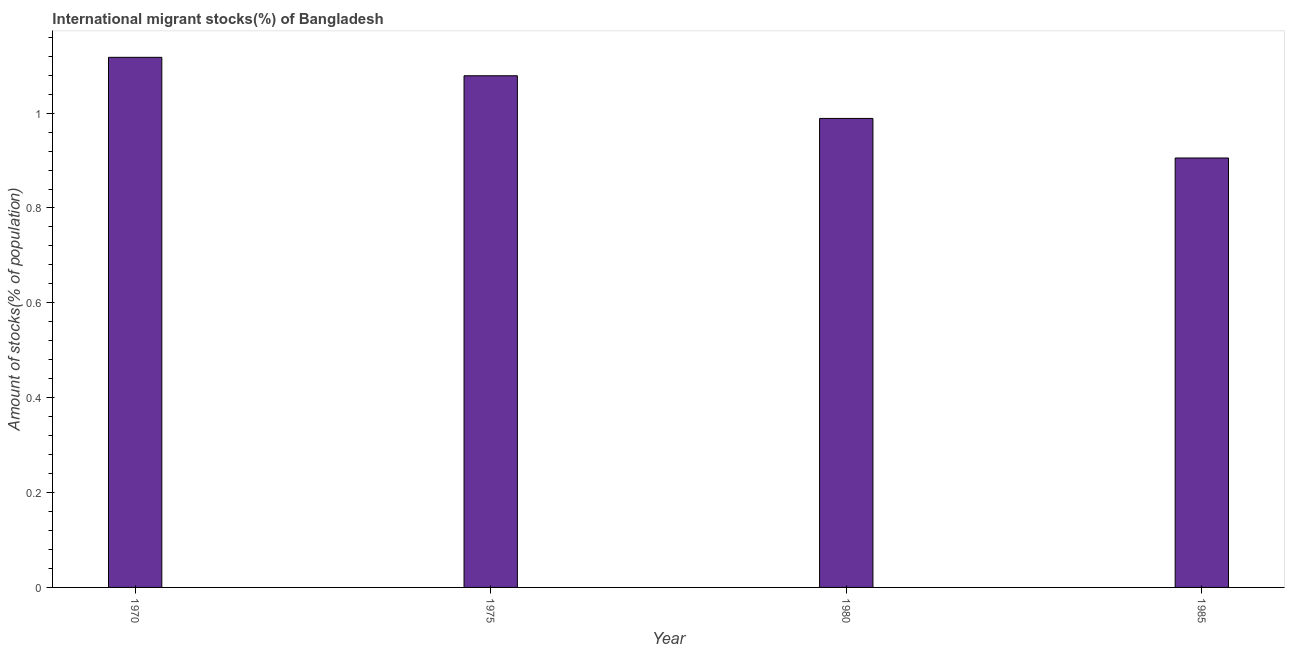What is the title of the graph?
Your answer should be very brief. International migrant stocks(%) of Bangladesh. What is the label or title of the Y-axis?
Ensure brevity in your answer.  Amount of stocks(% of population). What is the number of international migrant stocks in 1975?
Your response must be concise. 1.08. Across all years, what is the maximum number of international migrant stocks?
Keep it short and to the point. 1.12. Across all years, what is the minimum number of international migrant stocks?
Make the answer very short. 0.91. In which year was the number of international migrant stocks maximum?
Your response must be concise. 1970. In which year was the number of international migrant stocks minimum?
Provide a succinct answer. 1985. What is the sum of the number of international migrant stocks?
Your response must be concise. 4.09. What is the difference between the number of international migrant stocks in 1975 and 1985?
Give a very brief answer. 0.17. What is the median number of international migrant stocks?
Keep it short and to the point. 1.03. Do a majority of the years between 1975 and 1985 (inclusive) have number of international migrant stocks greater than 0.24 %?
Offer a terse response. Yes. What is the ratio of the number of international migrant stocks in 1970 to that in 1985?
Provide a succinct answer. 1.23. What is the difference between the highest and the second highest number of international migrant stocks?
Your response must be concise. 0.04. What is the difference between the highest and the lowest number of international migrant stocks?
Your answer should be compact. 0.21. Are all the bars in the graph horizontal?
Offer a very short reply. No. What is the Amount of stocks(% of population) in 1970?
Your answer should be compact. 1.12. What is the Amount of stocks(% of population) in 1975?
Your answer should be compact. 1.08. What is the Amount of stocks(% of population) of 1980?
Give a very brief answer. 0.99. What is the Amount of stocks(% of population) of 1985?
Offer a terse response. 0.91. What is the difference between the Amount of stocks(% of population) in 1970 and 1975?
Make the answer very short. 0.04. What is the difference between the Amount of stocks(% of population) in 1970 and 1980?
Your response must be concise. 0.13. What is the difference between the Amount of stocks(% of population) in 1970 and 1985?
Your answer should be very brief. 0.21. What is the difference between the Amount of stocks(% of population) in 1975 and 1980?
Your answer should be compact. 0.09. What is the difference between the Amount of stocks(% of population) in 1975 and 1985?
Ensure brevity in your answer.  0.17. What is the difference between the Amount of stocks(% of population) in 1980 and 1985?
Make the answer very short. 0.08. What is the ratio of the Amount of stocks(% of population) in 1970 to that in 1975?
Your response must be concise. 1.04. What is the ratio of the Amount of stocks(% of population) in 1970 to that in 1980?
Your answer should be very brief. 1.13. What is the ratio of the Amount of stocks(% of population) in 1970 to that in 1985?
Ensure brevity in your answer.  1.23. What is the ratio of the Amount of stocks(% of population) in 1975 to that in 1980?
Your answer should be compact. 1.09. What is the ratio of the Amount of stocks(% of population) in 1975 to that in 1985?
Offer a terse response. 1.19. What is the ratio of the Amount of stocks(% of population) in 1980 to that in 1985?
Your response must be concise. 1.09. 